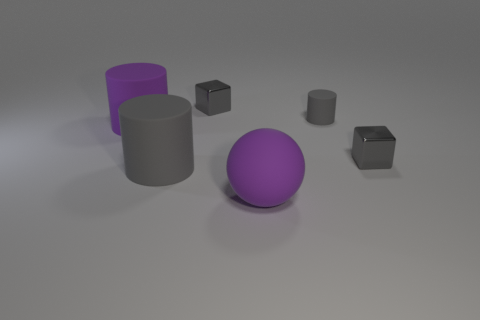Add 4 big objects. How many objects exist? 10 Subtract all spheres. How many objects are left? 5 Add 1 big gray rubber cylinders. How many big gray rubber cylinders exist? 2 Subtract 0 green blocks. How many objects are left? 6 Subtract all rubber cylinders. Subtract all big purple metallic balls. How many objects are left? 3 Add 5 gray matte things. How many gray matte things are left? 7 